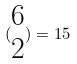Convert formula to latex. <formula><loc_0><loc_0><loc_500><loc_500>( \begin{matrix} 6 \\ 2 \end{matrix} ) = 1 5</formula> 